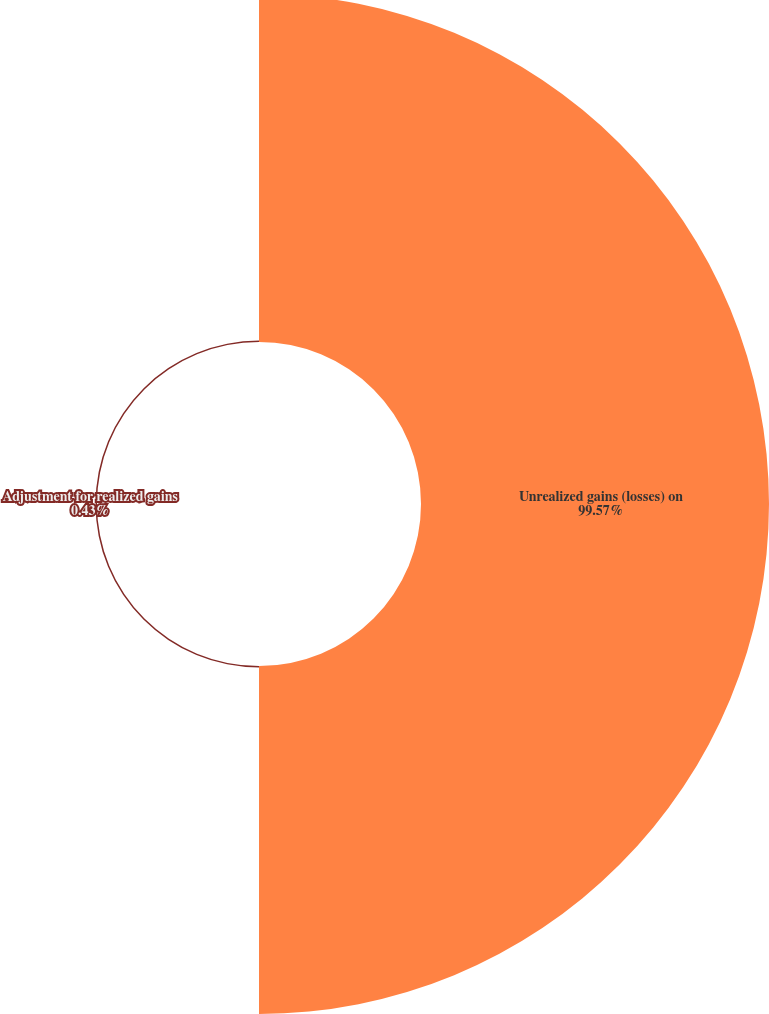Convert chart to OTSL. <chart><loc_0><loc_0><loc_500><loc_500><pie_chart><fcel>Unrealized gains (losses) on<fcel>Adjustment for realized gains<nl><fcel>99.57%<fcel>0.43%<nl></chart> 